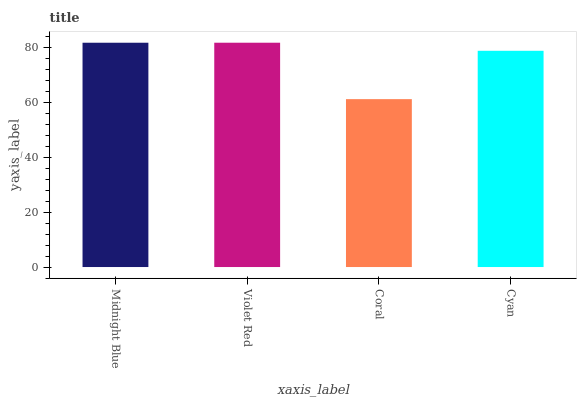Is Violet Red the minimum?
Answer yes or no. No. Is Coral the maximum?
Answer yes or no. No. Is Violet Red greater than Coral?
Answer yes or no. Yes. Is Coral less than Violet Red?
Answer yes or no. Yes. Is Coral greater than Violet Red?
Answer yes or no. No. Is Violet Red less than Coral?
Answer yes or no. No. Is Midnight Blue the high median?
Answer yes or no. Yes. Is Cyan the low median?
Answer yes or no. Yes. Is Violet Red the high median?
Answer yes or no. No. Is Violet Red the low median?
Answer yes or no. No. 